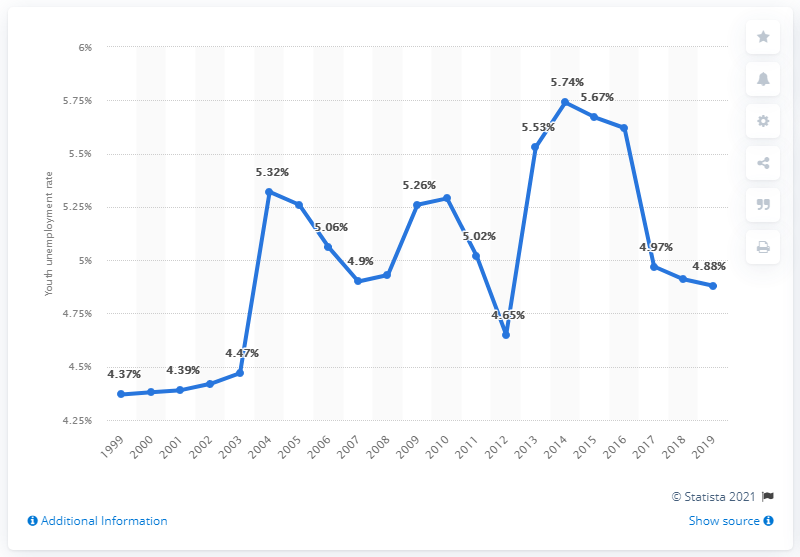What was the youth unemployment rate in Guatemala in 2019?
 4.88 